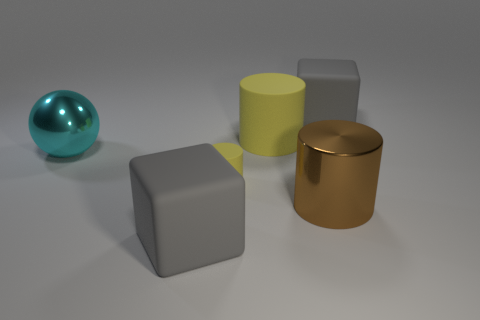There is a brown object that is the same shape as the tiny yellow thing; what material is it? The brown object, exhibiting a shiny surface and reflecting the environment just like the small yellow object, appears to be made of a polished metal. Specifically, it is suggestive of a copper or bronze material, given its warm, brownish hue. 